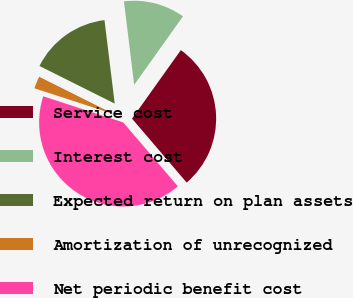Convert chart. <chart><loc_0><loc_0><loc_500><loc_500><pie_chart><fcel>Service cost<fcel>Interest cost<fcel>Expected return on plan assets<fcel>Amortization of unrecognized<fcel>Net periodic benefit cost<nl><fcel>28.89%<fcel>11.79%<fcel>15.68%<fcel>2.36%<fcel>41.27%<nl></chart> 